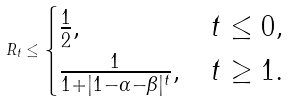<formula> <loc_0><loc_0><loc_500><loc_500>R _ { t } \leq \begin{cases} \frac { 1 } { 2 } , & t \leq 0 , \\ \frac { 1 } { 1 + | 1 - \alpha - \beta | ^ { t } } , & t \geq 1 . \end{cases}</formula> 